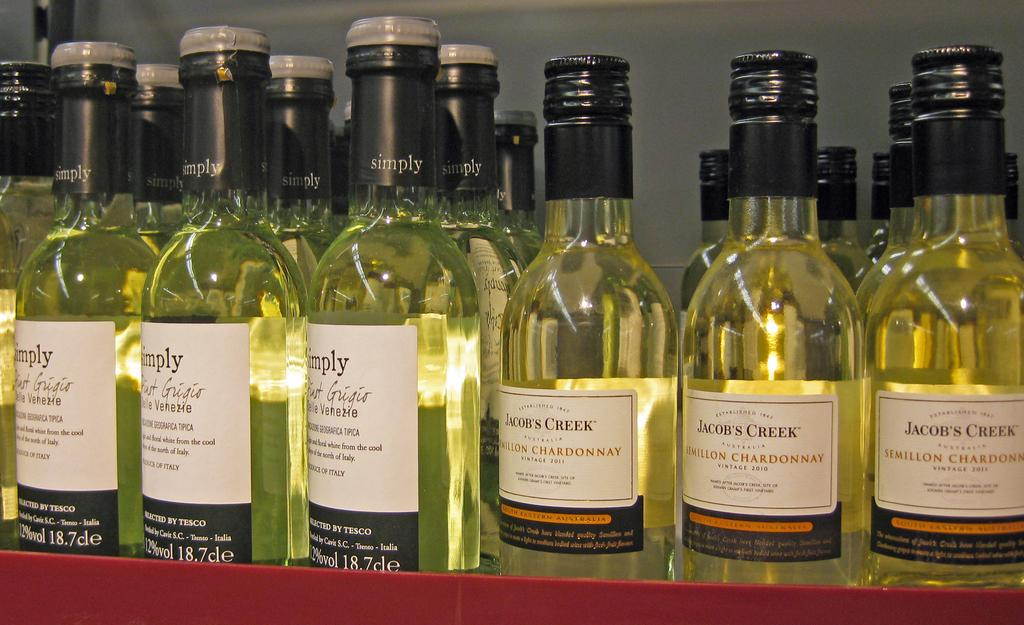<image>
Provide a brief description of the given image. Jacob's creek is well known for its bottle's of Chardonnay wine. 